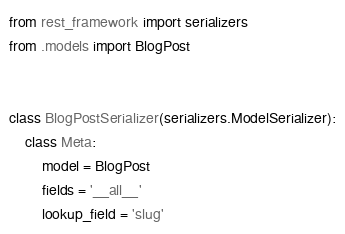Convert code to text. <code><loc_0><loc_0><loc_500><loc_500><_Python_>from rest_framework import serializers
from .models import BlogPost


class BlogPostSerializer(serializers.ModelSerializer):
    class Meta:
        model = BlogPost
        fields = '__all__'
        lookup_field = 'slug'</code> 